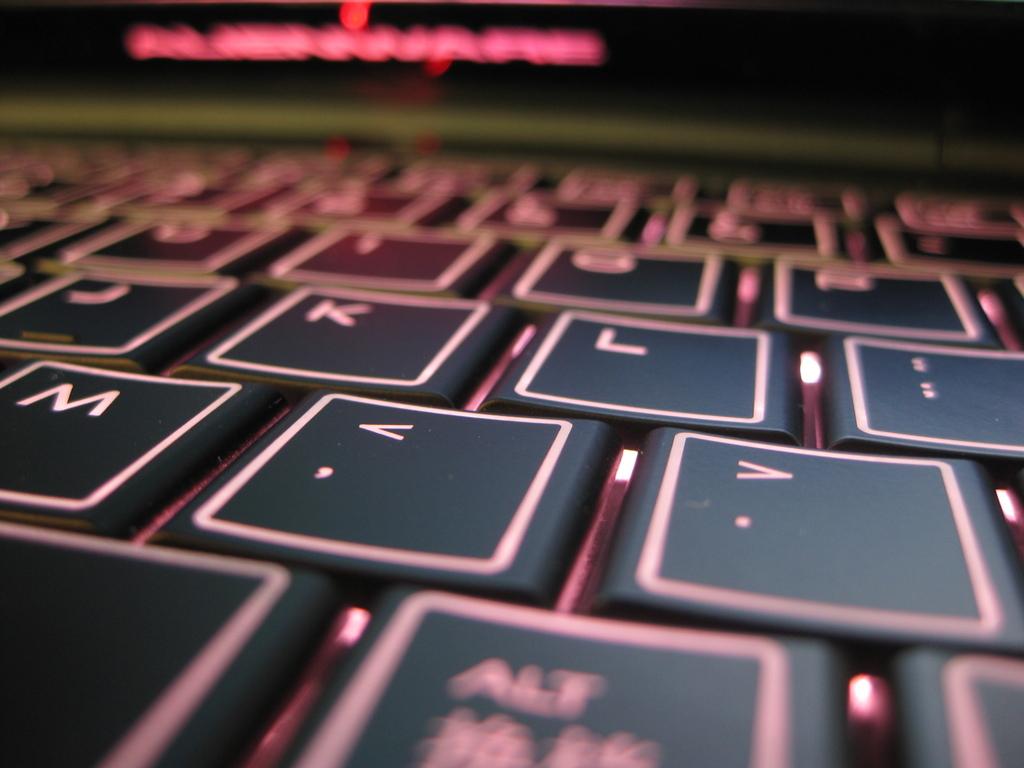What letter keys are shown?
Ensure brevity in your answer.  J k l m. What symbol is on the same key as the >?
Your answer should be very brief. . 